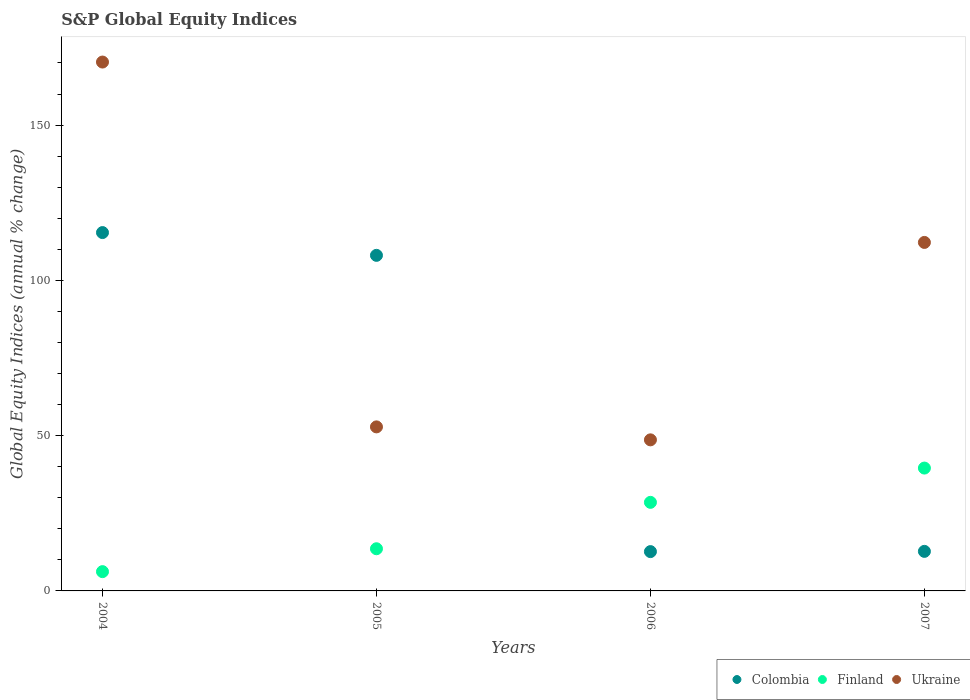How many different coloured dotlines are there?
Ensure brevity in your answer.  3. Is the number of dotlines equal to the number of legend labels?
Provide a succinct answer. Yes. What is the global equity indices in Ukraine in 2007?
Give a very brief answer. 112.22. Across all years, what is the maximum global equity indices in Ukraine?
Offer a terse response. 170.3. Across all years, what is the minimum global equity indices in Finland?
Provide a short and direct response. 6.21. In which year was the global equity indices in Ukraine maximum?
Provide a succinct answer. 2004. What is the total global equity indices in Ukraine in the graph?
Provide a succinct answer. 383.99. What is the difference between the global equity indices in Finland in 2004 and that in 2005?
Give a very brief answer. -7.37. What is the difference between the global equity indices in Colombia in 2004 and the global equity indices in Finland in 2005?
Provide a succinct answer. 101.81. What is the average global equity indices in Finland per year?
Provide a succinct answer. 21.97. In the year 2006, what is the difference between the global equity indices in Ukraine and global equity indices in Finland?
Your answer should be very brief. 20.12. In how many years, is the global equity indices in Finland greater than 70 %?
Your answer should be very brief. 0. What is the ratio of the global equity indices in Finland in 2004 to that in 2007?
Provide a short and direct response. 0.16. Is the global equity indices in Ukraine in 2005 less than that in 2006?
Ensure brevity in your answer.  No. Is the difference between the global equity indices in Ukraine in 2005 and 2007 greater than the difference between the global equity indices in Finland in 2005 and 2007?
Make the answer very short. No. What is the difference between the highest and the second highest global equity indices in Colombia?
Provide a succinct answer. 7.33. What is the difference between the highest and the lowest global equity indices in Colombia?
Ensure brevity in your answer.  102.73. Is the sum of the global equity indices in Ukraine in 2005 and 2007 greater than the maximum global equity indices in Finland across all years?
Offer a very short reply. Yes. Is the global equity indices in Finland strictly greater than the global equity indices in Colombia over the years?
Your answer should be very brief. No. How many dotlines are there?
Your answer should be very brief. 3. Does the graph contain any zero values?
Offer a very short reply. No. Where does the legend appear in the graph?
Ensure brevity in your answer.  Bottom right. How are the legend labels stacked?
Keep it short and to the point. Horizontal. What is the title of the graph?
Provide a succinct answer. S&P Global Equity Indices. What is the label or title of the X-axis?
Give a very brief answer. Years. What is the label or title of the Y-axis?
Give a very brief answer. Global Equity Indices (annual % change). What is the Global Equity Indices (annual % change) in Colombia in 2004?
Ensure brevity in your answer.  115.39. What is the Global Equity Indices (annual % change) in Finland in 2004?
Offer a terse response. 6.21. What is the Global Equity Indices (annual % change) of Ukraine in 2004?
Ensure brevity in your answer.  170.3. What is the Global Equity Indices (annual % change) in Colombia in 2005?
Make the answer very short. 108.06. What is the Global Equity Indices (annual % change) of Finland in 2005?
Ensure brevity in your answer.  13.58. What is the Global Equity Indices (annual % change) in Ukraine in 2005?
Your answer should be compact. 52.82. What is the Global Equity Indices (annual % change) of Colombia in 2006?
Offer a very short reply. 12.66. What is the Global Equity Indices (annual % change) of Finland in 2006?
Your response must be concise. 28.52. What is the Global Equity Indices (annual % change) of Ukraine in 2006?
Ensure brevity in your answer.  48.65. What is the Global Equity Indices (annual % change) of Colombia in 2007?
Give a very brief answer. 12.74. What is the Global Equity Indices (annual % change) of Finland in 2007?
Your answer should be compact. 39.56. What is the Global Equity Indices (annual % change) of Ukraine in 2007?
Keep it short and to the point. 112.22. Across all years, what is the maximum Global Equity Indices (annual % change) of Colombia?
Offer a terse response. 115.39. Across all years, what is the maximum Global Equity Indices (annual % change) in Finland?
Give a very brief answer. 39.56. Across all years, what is the maximum Global Equity Indices (annual % change) in Ukraine?
Provide a succinct answer. 170.3. Across all years, what is the minimum Global Equity Indices (annual % change) of Colombia?
Your answer should be very brief. 12.66. Across all years, what is the minimum Global Equity Indices (annual % change) of Finland?
Offer a very short reply. 6.21. Across all years, what is the minimum Global Equity Indices (annual % change) of Ukraine?
Your answer should be compact. 48.65. What is the total Global Equity Indices (annual % change) in Colombia in the graph?
Make the answer very short. 248.84. What is the total Global Equity Indices (annual % change) in Finland in the graph?
Your answer should be very brief. 87.87. What is the total Global Equity Indices (annual % change) of Ukraine in the graph?
Your response must be concise. 383.99. What is the difference between the Global Equity Indices (annual % change) of Colombia in 2004 and that in 2005?
Ensure brevity in your answer.  7.33. What is the difference between the Global Equity Indices (annual % change) in Finland in 2004 and that in 2005?
Your response must be concise. -7.37. What is the difference between the Global Equity Indices (annual % change) of Ukraine in 2004 and that in 2005?
Offer a terse response. 117.48. What is the difference between the Global Equity Indices (annual % change) of Colombia in 2004 and that in 2006?
Give a very brief answer. 102.73. What is the difference between the Global Equity Indices (annual % change) in Finland in 2004 and that in 2006?
Ensure brevity in your answer.  -22.31. What is the difference between the Global Equity Indices (annual % change) in Ukraine in 2004 and that in 2006?
Ensure brevity in your answer.  121.65. What is the difference between the Global Equity Indices (annual % change) in Colombia in 2004 and that in 2007?
Provide a short and direct response. 102.65. What is the difference between the Global Equity Indices (annual % change) in Finland in 2004 and that in 2007?
Your response must be concise. -33.35. What is the difference between the Global Equity Indices (annual % change) of Ukraine in 2004 and that in 2007?
Offer a terse response. 58.08. What is the difference between the Global Equity Indices (annual % change) of Colombia in 2005 and that in 2006?
Ensure brevity in your answer.  95.4. What is the difference between the Global Equity Indices (annual % change) of Finland in 2005 and that in 2006?
Make the answer very short. -14.94. What is the difference between the Global Equity Indices (annual % change) of Ukraine in 2005 and that in 2006?
Ensure brevity in your answer.  4.17. What is the difference between the Global Equity Indices (annual % change) of Colombia in 2005 and that in 2007?
Make the answer very short. 95.32. What is the difference between the Global Equity Indices (annual % change) in Finland in 2005 and that in 2007?
Your answer should be very brief. -25.98. What is the difference between the Global Equity Indices (annual % change) of Ukraine in 2005 and that in 2007?
Give a very brief answer. -59.4. What is the difference between the Global Equity Indices (annual % change) in Colombia in 2006 and that in 2007?
Offer a very short reply. -0.08. What is the difference between the Global Equity Indices (annual % change) of Finland in 2006 and that in 2007?
Ensure brevity in your answer.  -11.04. What is the difference between the Global Equity Indices (annual % change) in Ukraine in 2006 and that in 2007?
Your response must be concise. -63.57. What is the difference between the Global Equity Indices (annual % change) of Colombia in 2004 and the Global Equity Indices (annual % change) of Finland in 2005?
Provide a short and direct response. 101.81. What is the difference between the Global Equity Indices (annual % change) in Colombia in 2004 and the Global Equity Indices (annual % change) in Ukraine in 2005?
Your response must be concise. 62.57. What is the difference between the Global Equity Indices (annual % change) in Finland in 2004 and the Global Equity Indices (annual % change) in Ukraine in 2005?
Your answer should be compact. -46.61. What is the difference between the Global Equity Indices (annual % change) of Colombia in 2004 and the Global Equity Indices (annual % change) of Finland in 2006?
Your answer should be very brief. 86.87. What is the difference between the Global Equity Indices (annual % change) of Colombia in 2004 and the Global Equity Indices (annual % change) of Ukraine in 2006?
Provide a succinct answer. 66.74. What is the difference between the Global Equity Indices (annual % change) in Finland in 2004 and the Global Equity Indices (annual % change) in Ukraine in 2006?
Make the answer very short. -42.44. What is the difference between the Global Equity Indices (annual % change) of Colombia in 2004 and the Global Equity Indices (annual % change) of Finland in 2007?
Provide a short and direct response. 75.83. What is the difference between the Global Equity Indices (annual % change) in Colombia in 2004 and the Global Equity Indices (annual % change) in Ukraine in 2007?
Give a very brief answer. 3.17. What is the difference between the Global Equity Indices (annual % change) in Finland in 2004 and the Global Equity Indices (annual % change) in Ukraine in 2007?
Offer a very short reply. -106.01. What is the difference between the Global Equity Indices (annual % change) of Colombia in 2005 and the Global Equity Indices (annual % change) of Finland in 2006?
Make the answer very short. 79.53. What is the difference between the Global Equity Indices (annual % change) of Colombia in 2005 and the Global Equity Indices (annual % change) of Ukraine in 2006?
Offer a terse response. 59.41. What is the difference between the Global Equity Indices (annual % change) in Finland in 2005 and the Global Equity Indices (annual % change) in Ukraine in 2006?
Your answer should be compact. -35.07. What is the difference between the Global Equity Indices (annual % change) in Colombia in 2005 and the Global Equity Indices (annual % change) in Finland in 2007?
Provide a succinct answer. 68.5. What is the difference between the Global Equity Indices (annual % change) in Colombia in 2005 and the Global Equity Indices (annual % change) in Ukraine in 2007?
Provide a succinct answer. -4.16. What is the difference between the Global Equity Indices (annual % change) in Finland in 2005 and the Global Equity Indices (annual % change) in Ukraine in 2007?
Provide a short and direct response. -98.64. What is the difference between the Global Equity Indices (annual % change) of Colombia in 2006 and the Global Equity Indices (annual % change) of Finland in 2007?
Your answer should be compact. -26.9. What is the difference between the Global Equity Indices (annual % change) of Colombia in 2006 and the Global Equity Indices (annual % change) of Ukraine in 2007?
Ensure brevity in your answer.  -99.56. What is the difference between the Global Equity Indices (annual % change) in Finland in 2006 and the Global Equity Indices (annual % change) in Ukraine in 2007?
Your answer should be very brief. -83.7. What is the average Global Equity Indices (annual % change) in Colombia per year?
Your answer should be very brief. 62.21. What is the average Global Equity Indices (annual % change) in Finland per year?
Your answer should be compact. 21.97. What is the average Global Equity Indices (annual % change) of Ukraine per year?
Your response must be concise. 96. In the year 2004, what is the difference between the Global Equity Indices (annual % change) in Colombia and Global Equity Indices (annual % change) in Finland?
Offer a terse response. 109.18. In the year 2004, what is the difference between the Global Equity Indices (annual % change) in Colombia and Global Equity Indices (annual % change) in Ukraine?
Provide a succinct answer. -54.91. In the year 2004, what is the difference between the Global Equity Indices (annual % change) in Finland and Global Equity Indices (annual % change) in Ukraine?
Provide a succinct answer. -164.09. In the year 2005, what is the difference between the Global Equity Indices (annual % change) of Colombia and Global Equity Indices (annual % change) of Finland?
Provide a short and direct response. 94.48. In the year 2005, what is the difference between the Global Equity Indices (annual % change) of Colombia and Global Equity Indices (annual % change) of Ukraine?
Keep it short and to the point. 55.24. In the year 2005, what is the difference between the Global Equity Indices (annual % change) in Finland and Global Equity Indices (annual % change) in Ukraine?
Your response must be concise. -39.24. In the year 2006, what is the difference between the Global Equity Indices (annual % change) in Colombia and Global Equity Indices (annual % change) in Finland?
Your answer should be compact. -15.86. In the year 2006, what is the difference between the Global Equity Indices (annual % change) of Colombia and Global Equity Indices (annual % change) of Ukraine?
Your answer should be compact. -35.99. In the year 2006, what is the difference between the Global Equity Indices (annual % change) in Finland and Global Equity Indices (annual % change) in Ukraine?
Your response must be concise. -20.12. In the year 2007, what is the difference between the Global Equity Indices (annual % change) in Colombia and Global Equity Indices (annual % change) in Finland?
Your answer should be compact. -26.82. In the year 2007, what is the difference between the Global Equity Indices (annual % change) of Colombia and Global Equity Indices (annual % change) of Ukraine?
Your response must be concise. -99.48. In the year 2007, what is the difference between the Global Equity Indices (annual % change) of Finland and Global Equity Indices (annual % change) of Ukraine?
Offer a terse response. -72.66. What is the ratio of the Global Equity Indices (annual % change) of Colombia in 2004 to that in 2005?
Your answer should be very brief. 1.07. What is the ratio of the Global Equity Indices (annual % change) of Finland in 2004 to that in 2005?
Your answer should be very brief. 0.46. What is the ratio of the Global Equity Indices (annual % change) in Ukraine in 2004 to that in 2005?
Keep it short and to the point. 3.22. What is the ratio of the Global Equity Indices (annual % change) of Colombia in 2004 to that in 2006?
Provide a succinct answer. 9.12. What is the ratio of the Global Equity Indices (annual % change) of Finland in 2004 to that in 2006?
Ensure brevity in your answer.  0.22. What is the ratio of the Global Equity Indices (annual % change) of Ukraine in 2004 to that in 2006?
Provide a succinct answer. 3.5. What is the ratio of the Global Equity Indices (annual % change) in Colombia in 2004 to that in 2007?
Make the answer very short. 9.06. What is the ratio of the Global Equity Indices (annual % change) of Finland in 2004 to that in 2007?
Offer a very short reply. 0.16. What is the ratio of the Global Equity Indices (annual % change) in Ukraine in 2004 to that in 2007?
Offer a very short reply. 1.52. What is the ratio of the Global Equity Indices (annual % change) of Colombia in 2005 to that in 2006?
Keep it short and to the point. 8.54. What is the ratio of the Global Equity Indices (annual % change) in Finland in 2005 to that in 2006?
Provide a short and direct response. 0.48. What is the ratio of the Global Equity Indices (annual % change) in Ukraine in 2005 to that in 2006?
Ensure brevity in your answer.  1.09. What is the ratio of the Global Equity Indices (annual % change) in Colombia in 2005 to that in 2007?
Give a very brief answer. 8.48. What is the ratio of the Global Equity Indices (annual % change) in Finland in 2005 to that in 2007?
Make the answer very short. 0.34. What is the ratio of the Global Equity Indices (annual % change) of Ukraine in 2005 to that in 2007?
Provide a short and direct response. 0.47. What is the ratio of the Global Equity Indices (annual % change) of Finland in 2006 to that in 2007?
Offer a very short reply. 0.72. What is the ratio of the Global Equity Indices (annual % change) in Ukraine in 2006 to that in 2007?
Your answer should be compact. 0.43. What is the difference between the highest and the second highest Global Equity Indices (annual % change) in Colombia?
Offer a terse response. 7.33. What is the difference between the highest and the second highest Global Equity Indices (annual % change) in Finland?
Your answer should be compact. 11.04. What is the difference between the highest and the second highest Global Equity Indices (annual % change) of Ukraine?
Ensure brevity in your answer.  58.08. What is the difference between the highest and the lowest Global Equity Indices (annual % change) of Colombia?
Make the answer very short. 102.73. What is the difference between the highest and the lowest Global Equity Indices (annual % change) of Finland?
Your answer should be compact. 33.35. What is the difference between the highest and the lowest Global Equity Indices (annual % change) of Ukraine?
Make the answer very short. 121.65. 